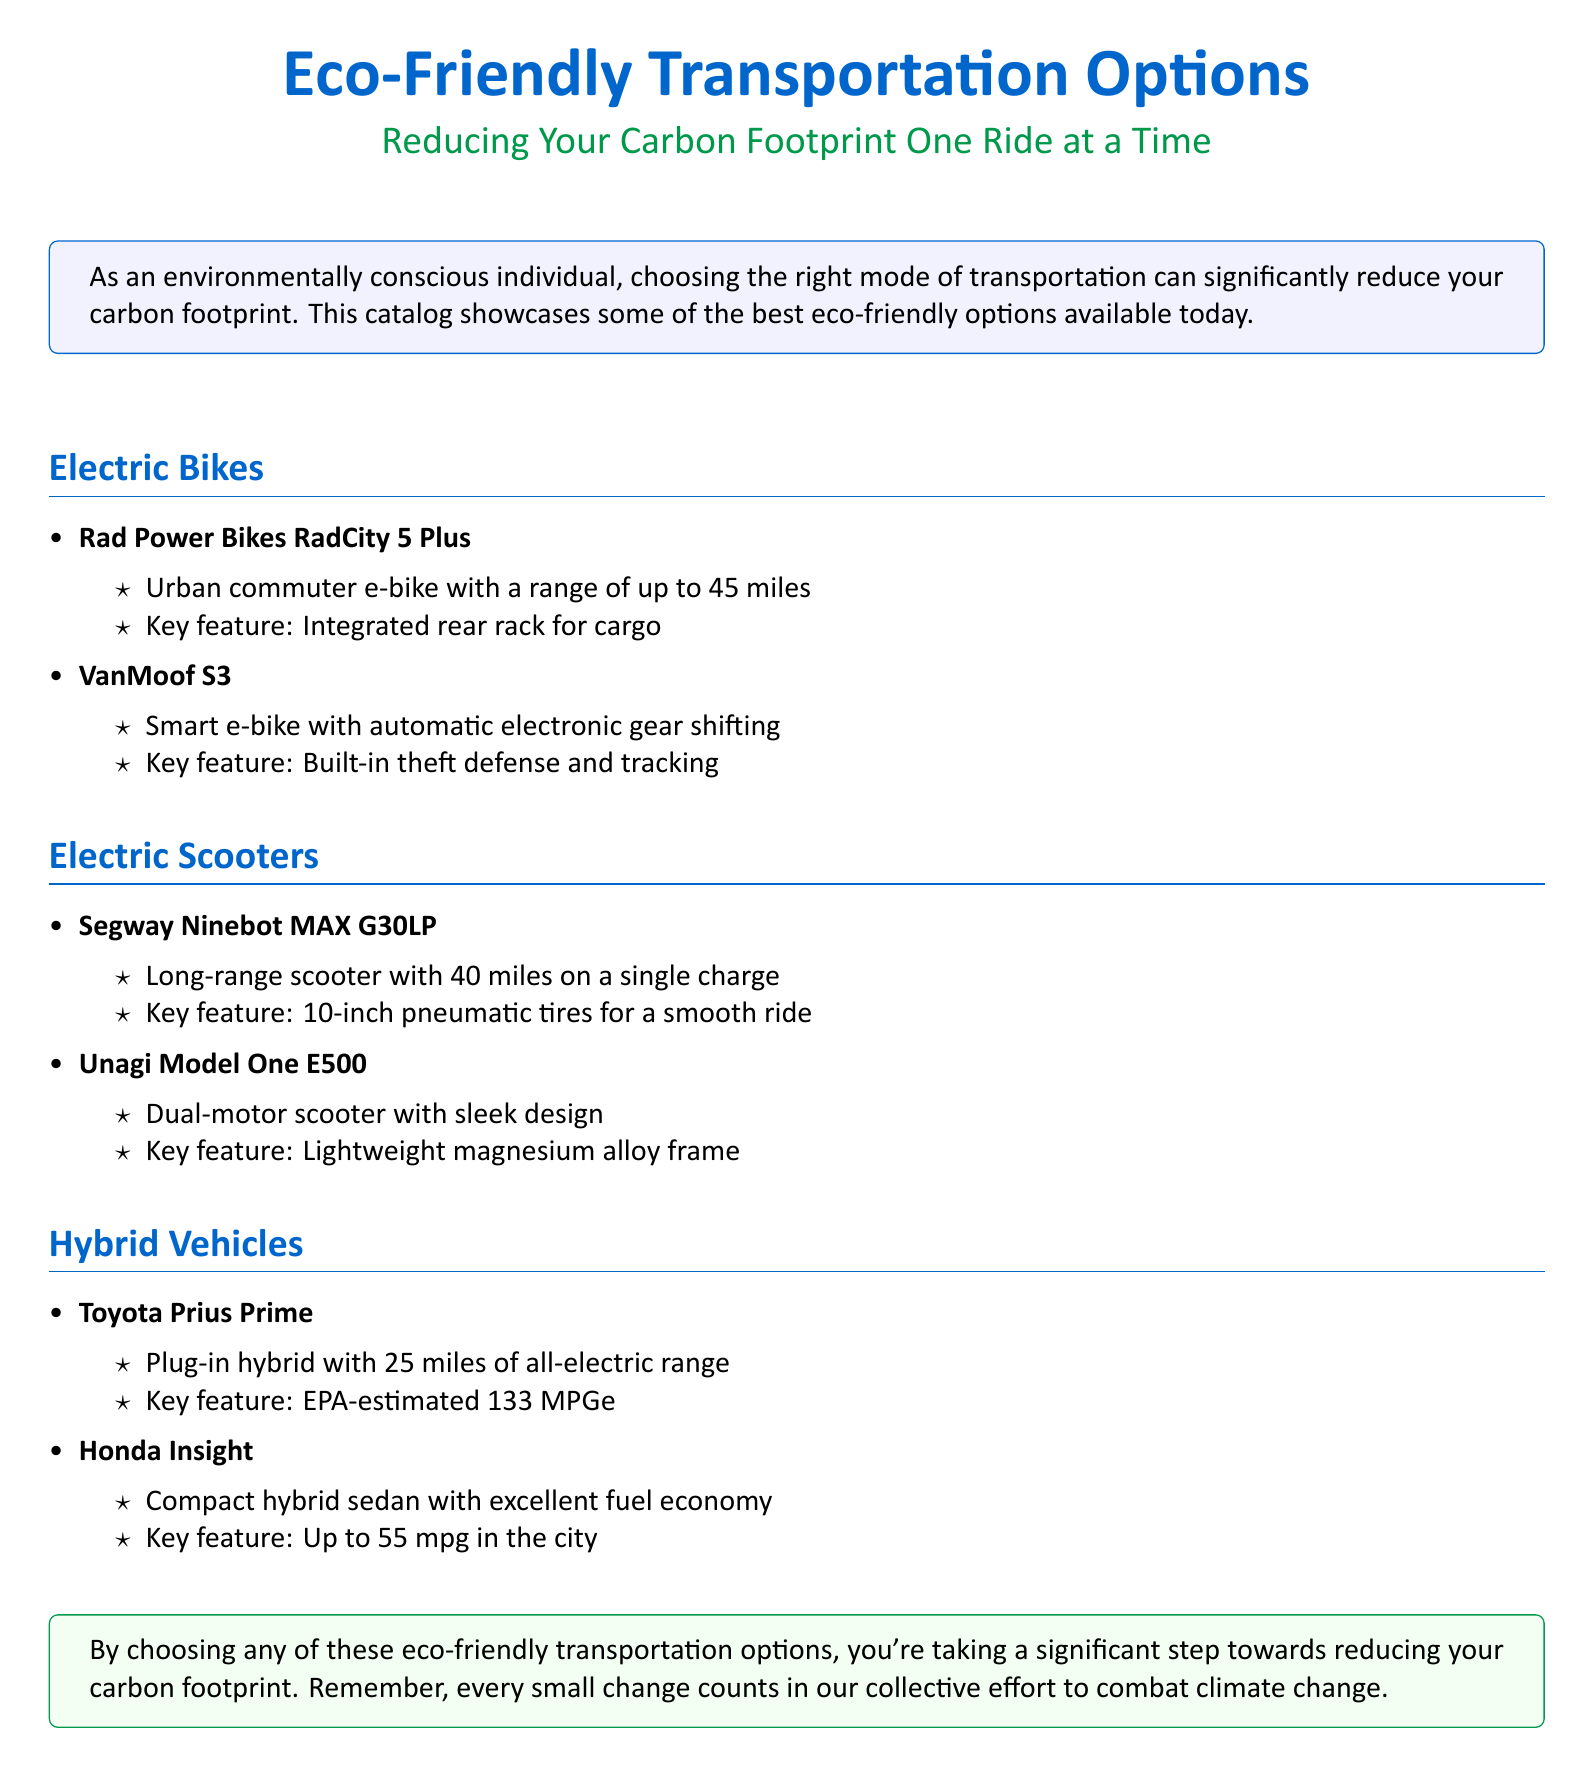What is the range of the Rad Power Bikes RadCity 5 Plus? The Rad Power Bikes RadCity 5 Plus has a range of up to 45 miles.
Answer: 45 miles What feature does the VanMoof S3 offer for security? The VanMoof S3 features built-in theft defense and tracking.
Answer: Theft defense and tracking How many miles can the Segway Ninebot MAX G30LP travel on a single charge? The Segway Ninebot MAX G30LP can travel up to 40 miles on a single charge.
Answer: 40 miles What is the EPA-estimated MPGe of the Toyota Prius Prime? The Toyota Prius Prime has an EPA-estimated 133 MPGe.
Answer: 133 MPGe Which eco-friendly option is a plug-in hybrid? The Toyota Prius Prime is a plug-in hybrid.
Answer: Toyota Prius Prime What is the main benefit of the Unagi Model One E500's design? The main benefit of the Unagi Model One E500 is its lightweight magnesium alloy frame.
Answer: Lightweight magnesium alloy frame What type of bike is the Rad Power Bikes RadCity 5 Plus? The Rad Power Bikes RadCity 5 Plus is an urban commuter e-bike.
Answer: Urban commuter e-bike Which hybrid vehicle has a city mpg of up to 55? The Honda Insight has a city mpg of up to 55.
Answer: Honda Insight How does choosing eco-friendly transportation impact your carbon footprint? Choosing eco-friendly transportation significantly reduces your carbon footprint.
Answer: Reduces carbon footprint 